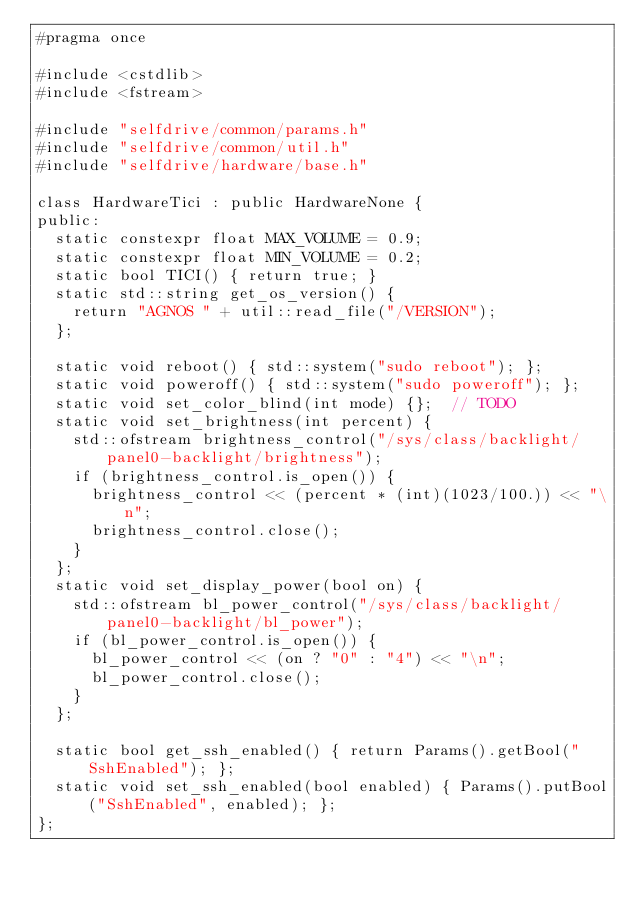Convert code to text. <code><loc_0><loc_0><loc_500><loc_500><_C_>#pragma once

#include <cstdlib>
#include <fstream>

#include "selfdrive/common/params.h"
#include "selfdrive/common/util.h"
#include "selfdrive/hardware/base.h"

class HardwareTici : public HardwareNone {
public:
  static constexpr float MAX_VOLUME = 0.9;
  static constexpr float MIN_VOLUME = 0.2;
  static bool TICI() { return true; }
  static std::string get_os_version() {
    return "AGNOS " + util::read_file("/VERSION");
  };

  static void reboot() { std::system("sudo reboot"); };
  static void poweroff() { std::system("sudo poweroff"); };
  static void set_color_blind(int mode) {};  // TODO
  static void set_brightness(int percent) {
    std::ofstream brightness_control("/sys/class/backlight/panel0-backlight/brightness");
    if (brightness_control.is_open()) {
      brightness_control << (percent * (int)(1023/100.)) << "\n";
      brightness_control.close();
    }
  };
  static void set_display_power(bool on) {
    std::ofstream bl_power_control("/sys/class/backlight/panel0-backlight/bl_power");
    if (bl_power_control.is_open()) {
      bl_power_control << (on ? "0" : "4") << "\n";
      bl_power_control.close();
    }
  };

  static bool get_ssh_enabled() { return Params().getBool("SshEnabled"); };
  static void set_ssh_enabled(bool enabled) { Params().putBool("SshEnabled", enabled); };
};
</code> 